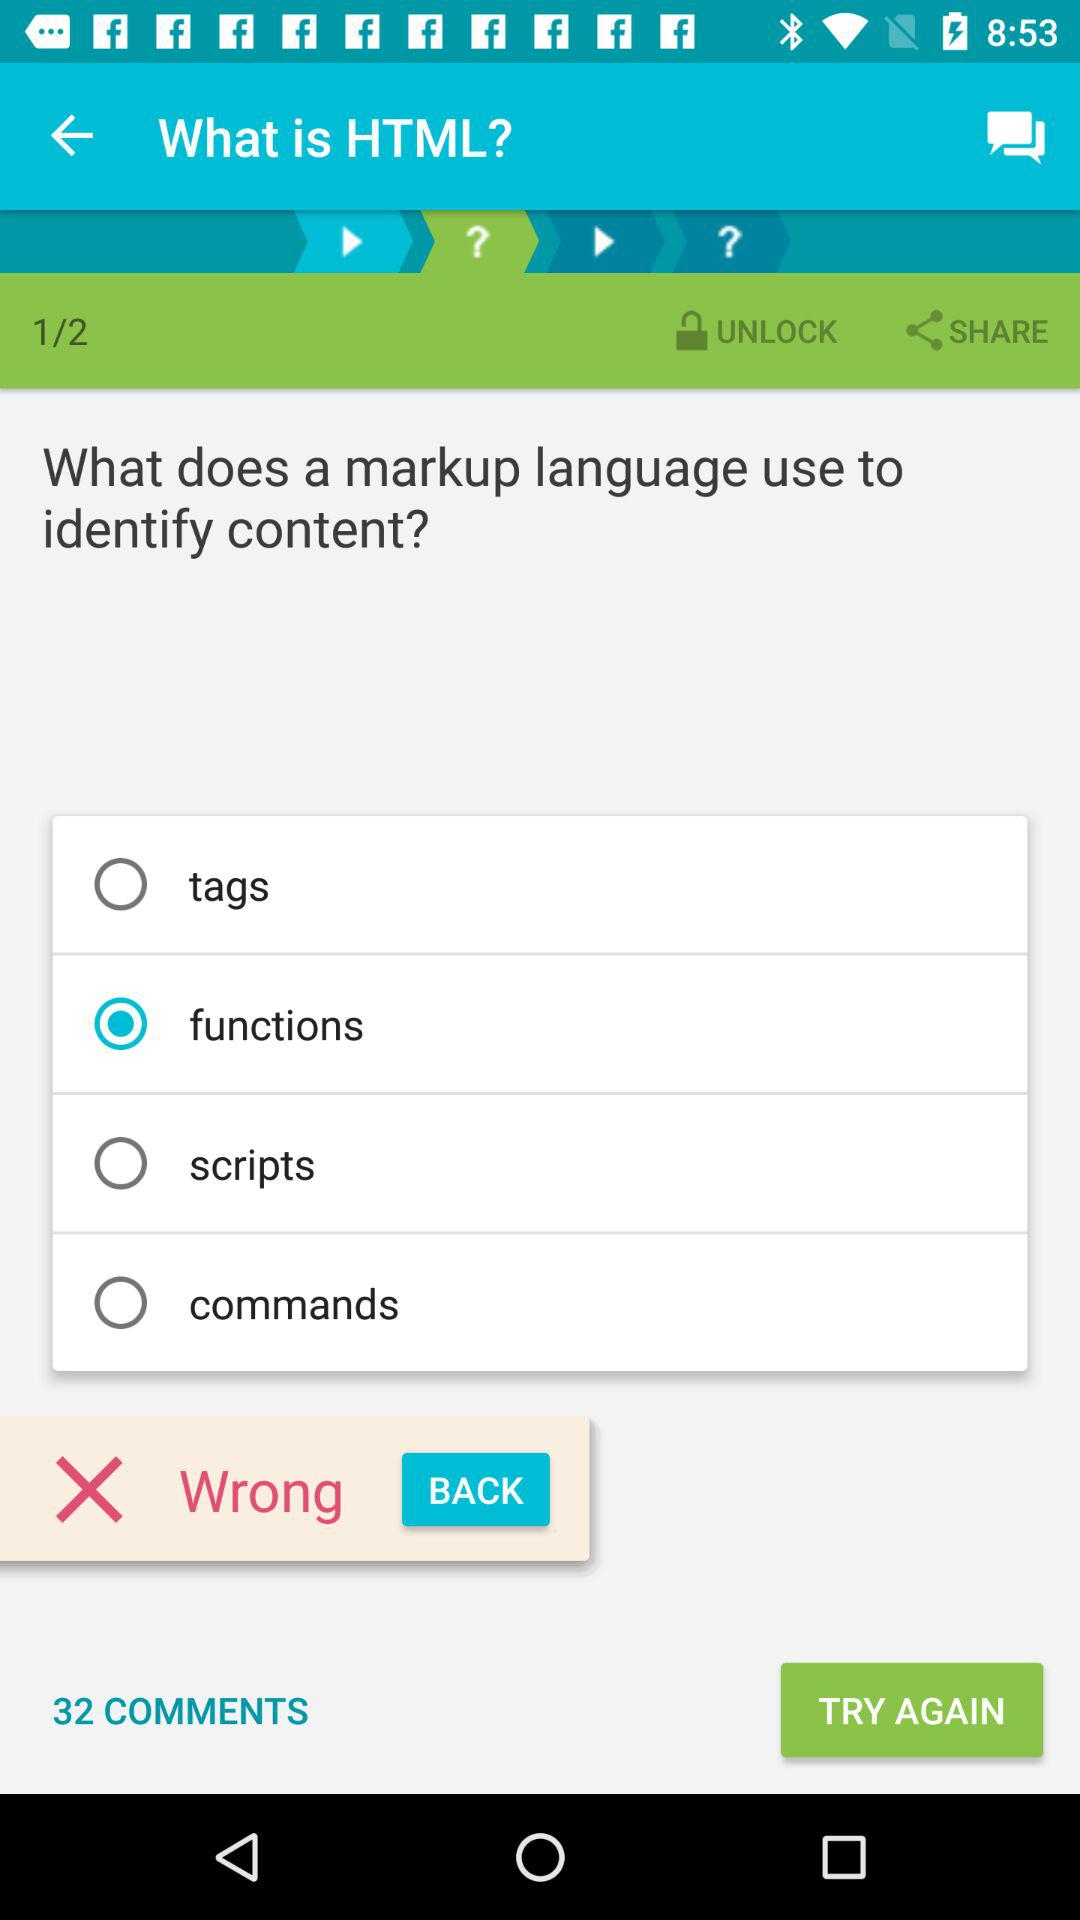How many comments in total are there? There are 32 comments in total. 